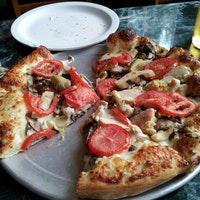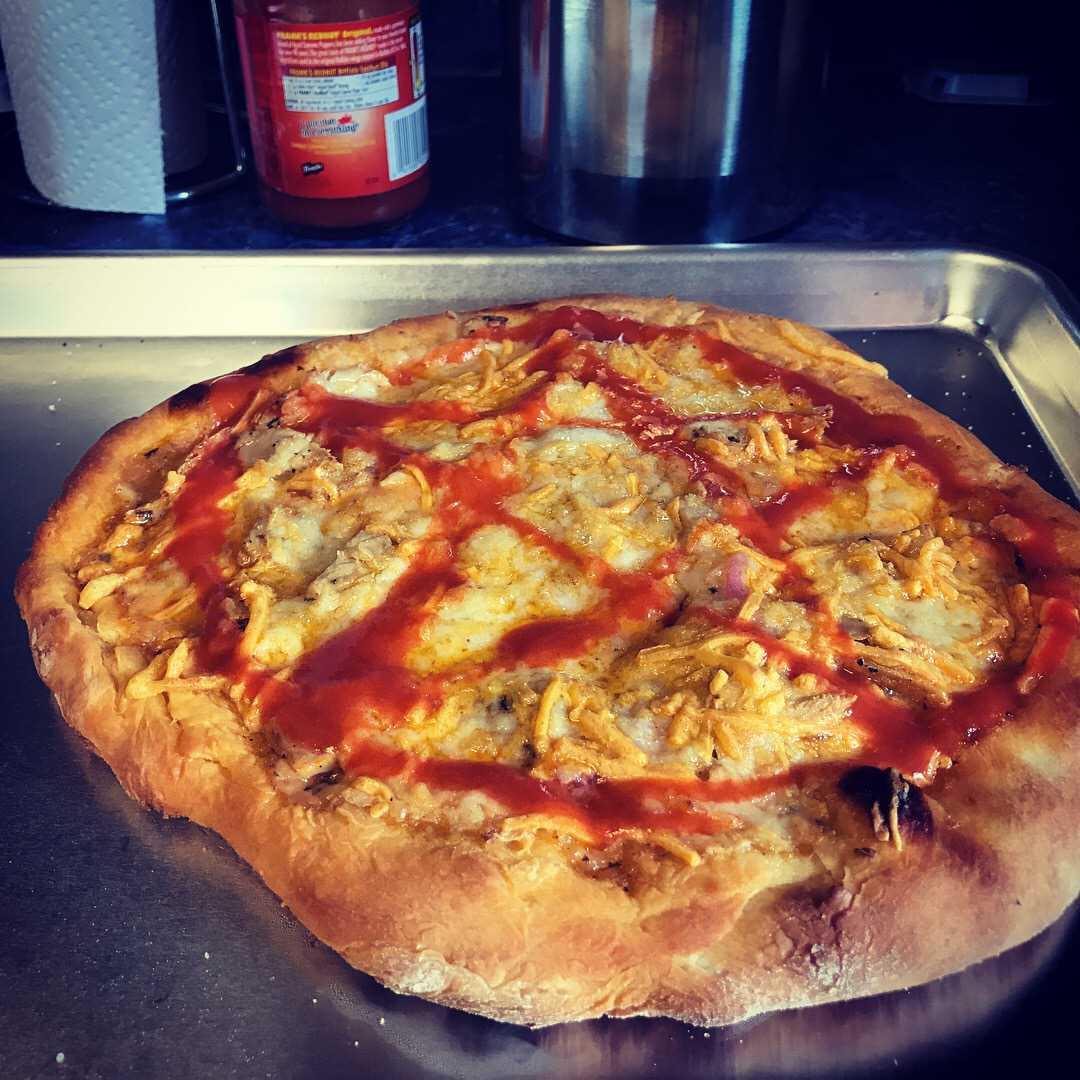The first image is the image on the left, the second image is the image on the right. Evaluate the accuracy of this statement regarding the images: "One image shows a whole pizza, and the other image shows a pizza on a round gray tray, with multiple slices missing.". Is it true? Answer yes or no. Yes. The first image is the image on the left, the second image is the image on the right. For the images displayed, is the sentence "The pizza in the image on the right is topped with round pepperoni slices." factually correct? Answer yes or no. No. 